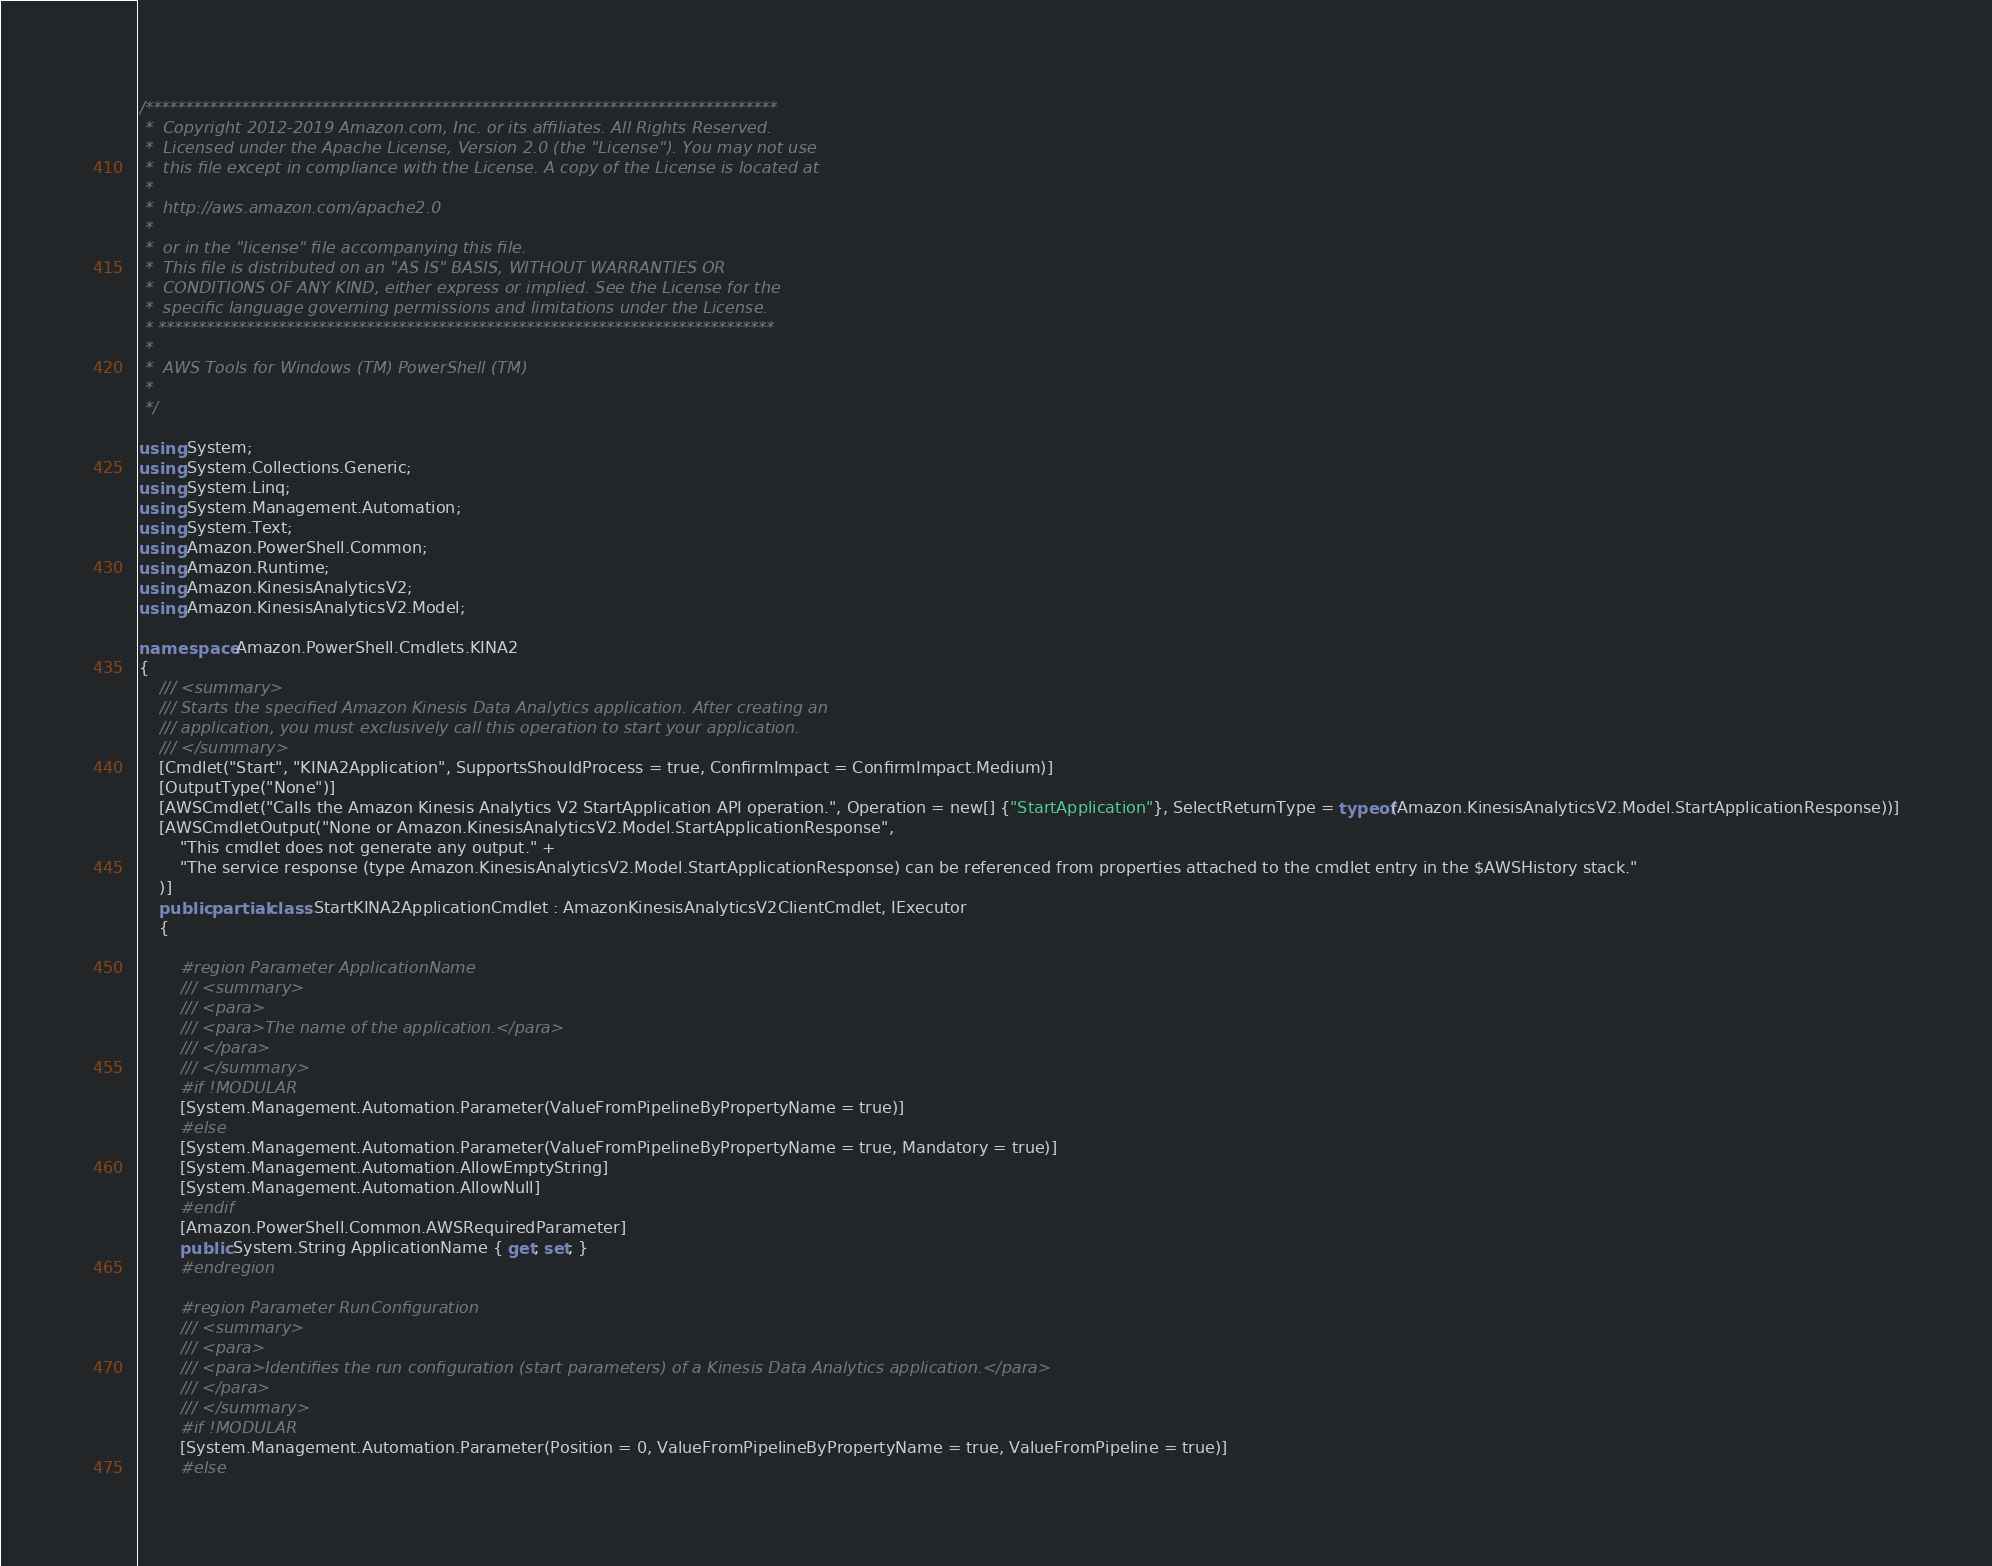Convert code to text. <code><loc_0><loc_0><loc_500><loc_500><_C#_>/*******************************************************************************
 *  Copyright 2012-2019 Amazon.com, Inc. or its affiliates. All Rights Reserved.
 *  Licensed under the Apache License, Version 2.0 (the "License"). You may not use
 *  this file except in compliance with the License. A copy of the License is located at
 *
 *  http://aws.amazon.com/apache2.0
 *
 *  or in the "license" file accompanying this file.
 *  This file is distributed on an "AS IS" BASIS, WITHOUT WARRANTIES OR
 *  CONDITIONS OF ANY KIND, either express or implied. See the License for the
 *  specific language governing permissions and limitations under the License.
 * *****************************************************************************
 *
 *  AWS Tools for Windows (TM) PowerShell (TM)
 *
 */

using System;
using System.Collections.Generic;
using System.Linq;
using System.Management.Automation;
using System.Text;
using Amazon.PowerShell.Common;
using Amazon.Runtime;
using Amazon.KinesisAnalyticsV2;
using Amazon.KinesisAnalyticsV2.Model;

namespace Amazon.PowerShell.Cmdlets.KINA2
{
    /// <summary>
    /// Starts the specified Amazon Kinesis Data Analytics application. After creating an
    /// application, you must exclusively call this operation to start your application.
    /// </summary>
    [Cmdlet("Start", "KINA2Application", SupportsShouldProcess = true, ConfirmImpact = ConfirmImpact.Medium)]
    [OutputType("None")]
    [AWSCmdlet("Calls the Amazon Kinesis Analytics V2 StartApplication API operation.", Operation = new[] {"StartApplication"}, SelectReturnType = typeof(Amazon.KinesisAnalyticsV2.Model.StartApplicationResponse))]
    [AWSCmdletOutput("None or Amazon.KinesisAnalyticsV2.Model.StartApplicationResponse",
        "This cmdlet does not generate any output." +
        "The service response (type Amazon.KinesisAnalyticsV2.Model.StartApplicationResponse) can be referenced from properties attached to the cmdlet entry in the $AWSHistory stack."
    )]
    public partial class StartKINA2ApplicationCmdlet : AmazonKinesisAnalyticsV2ClientCmdlet, IExecutor
    {
        
        #region Parameter ApplicationName
        /// <summary>
        /// <para>
        /// <para>The name of the application.</para>
        /// </para>
        /// </summary>
        #if !MODULAR
        [System.Management.Automation.Parameter(ValueFromPipelineByPropertyName = true)]
        #else
        [System.Management.Automation.Parameter(ValueFromPipelineByPropertyName = true, Mandatory = true)]
        [System.Management.Automation.AllowEmptyString]
        [System.Management.Automation.AllowNull]
        #endif
        [Amazon.PowerShell.Common.AWSRequiredParameter]
        public System.String ApplicationName { get; set; }
        #endregion
        
        #region Parameter RunConfiguration
        /// <summary>
        /// <para>
        /// <para>Identifies the run configuration (start parameters) of a Kinesis Data Analytics application.</para>
        /// </para>
        /// </summary>
        #if !MODULAR
        [System.Management.Automation.Parameter(Position = 0, ValueFromPipelineByPropertyName = true, ValueFromPipeline = true)]
        #else</code> 